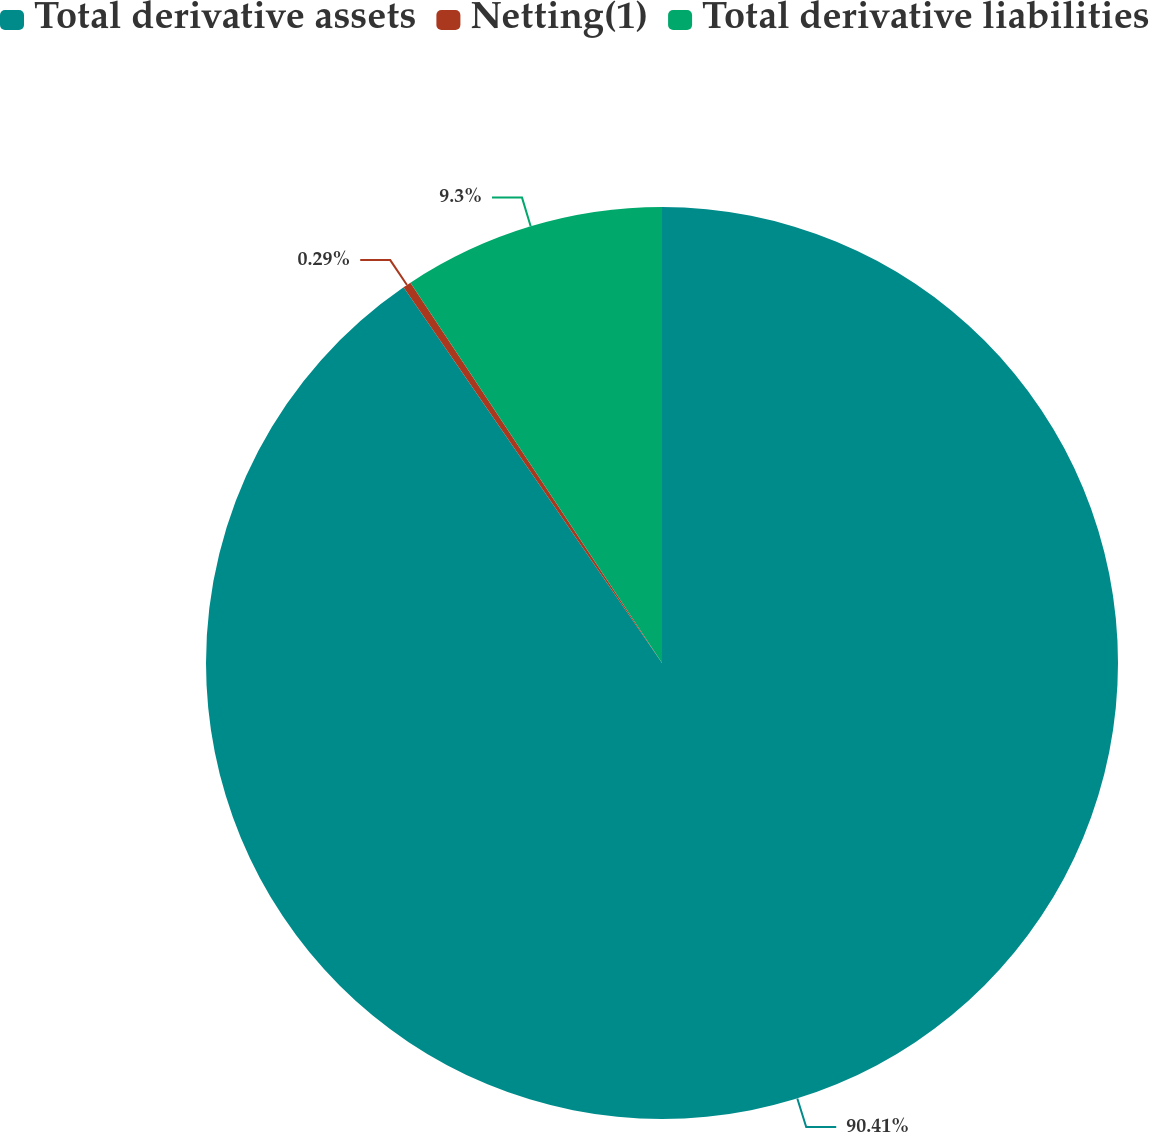Convert chart to OTSL. <chart><loc_0><loc_0><loc_500><loc_500><pie_chart><fcel>Total derivative assets<fcel>Netting(1)<fcel>Total derivative liabilities<nl><fcel>90.41%<fcel>0.29%<fcel>9.3%<nl></chart> 